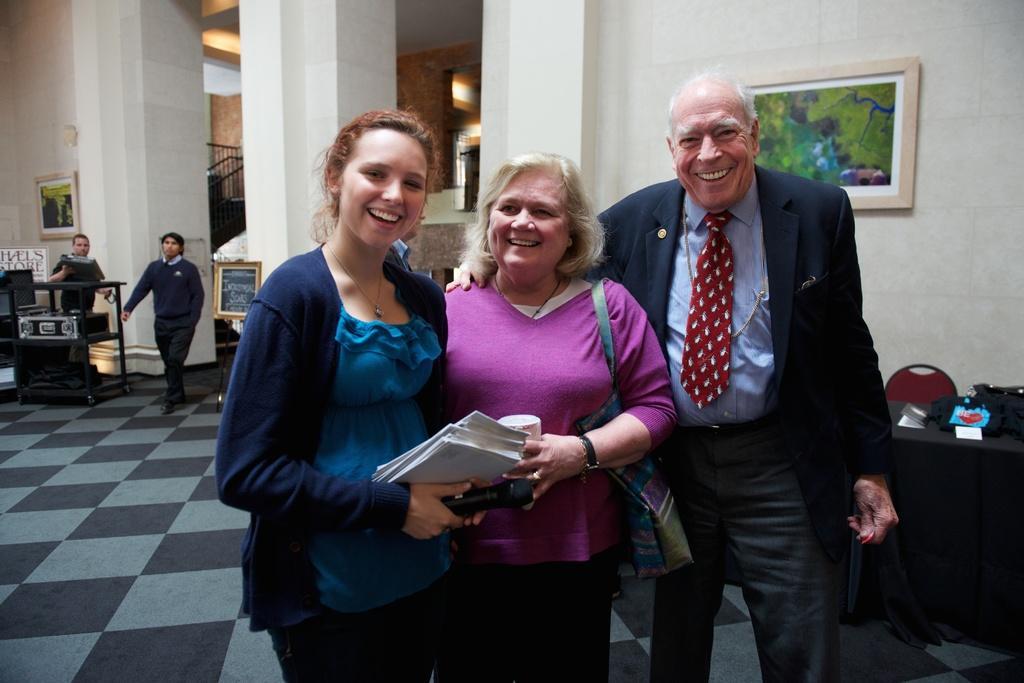Please provide a concise description of this image. In the center of the image we can see three persons standing on the floor. On the right side of the image we can table, chair, bag and a photo frame. In the background we can see wall, person, boat, some container, stairs and photo frame. 